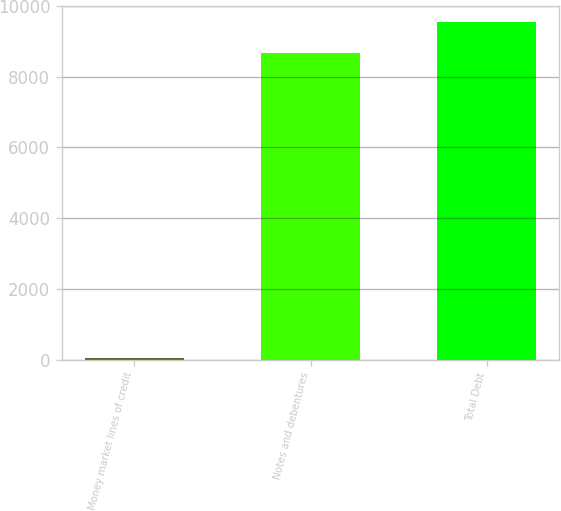<chart> <loc_0><loc_0><loc_500><loc_500><bar_chart><fcel>Money market lines of credit<fcel>Notes and debentures<fcel>Total Debt<nl><fcel>31<fcel>8673<fcel>9540.3<nl></chart> 